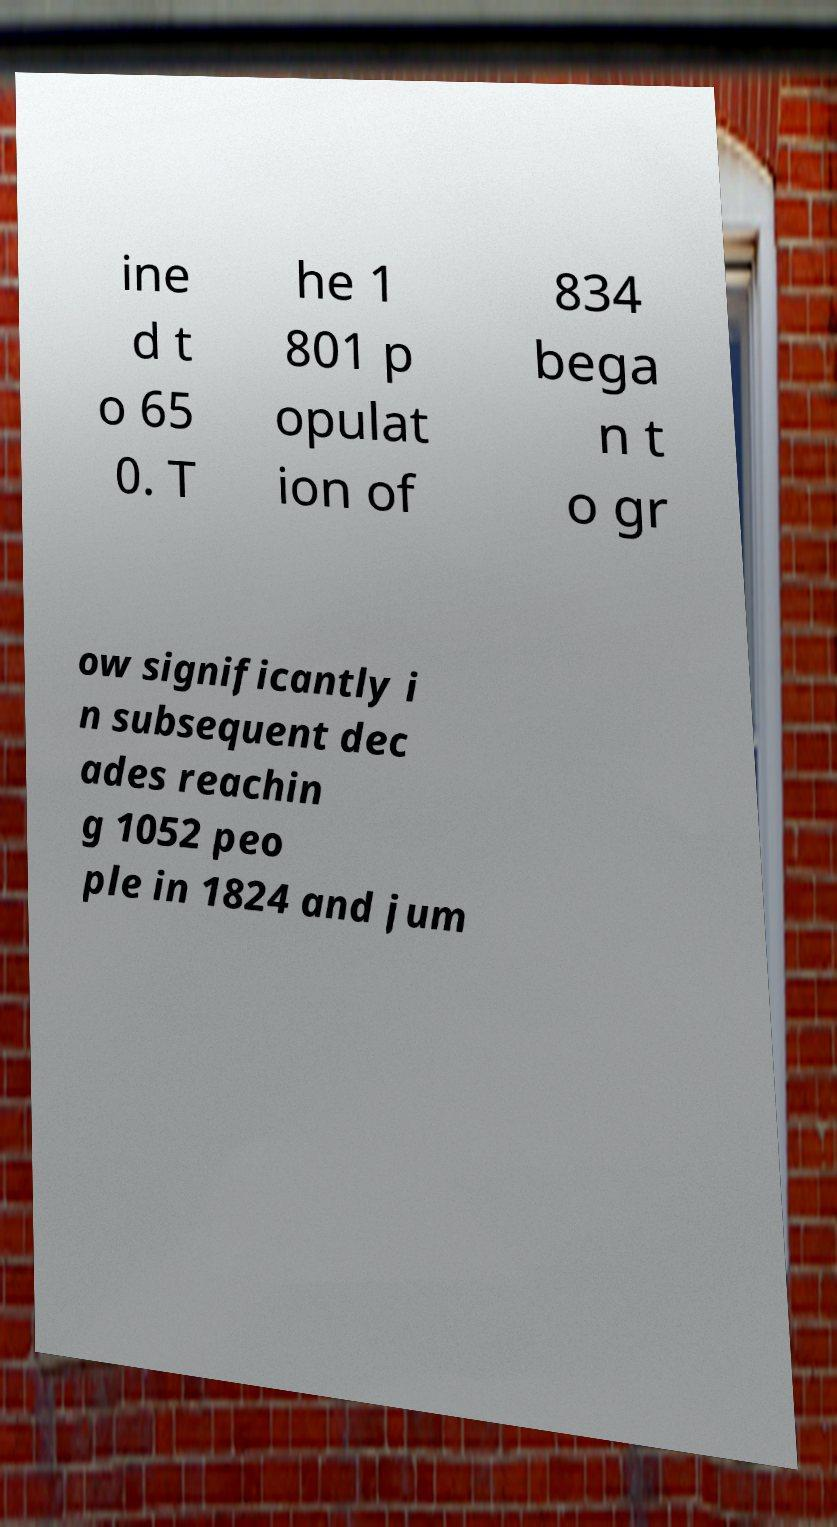Please read and relay the text visible in this image. What does it say? ine d t o 65 0. T he 1 801 p opulat ion of 834 bega n t o gr ow significantly i n subsequent dec ades reachin g 1052 peo ple in 1824 and jum 